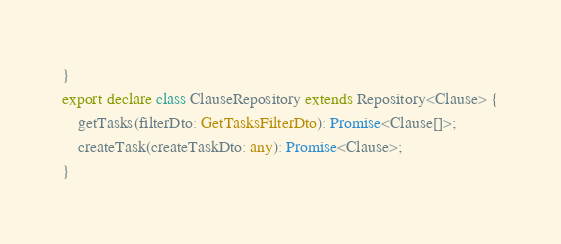Convert code to text. <code><loc_0><loc_0><loc_500><loc_500><_TypeScript_>}
export declare class ClauseRepository extends Repository<Clause> {
    getTasks(filterDto: GetTasksFilterDto): Promise<Clause[]>;
    createTask(createTaskDto: any): Promise<Clause>;
}
</code> 